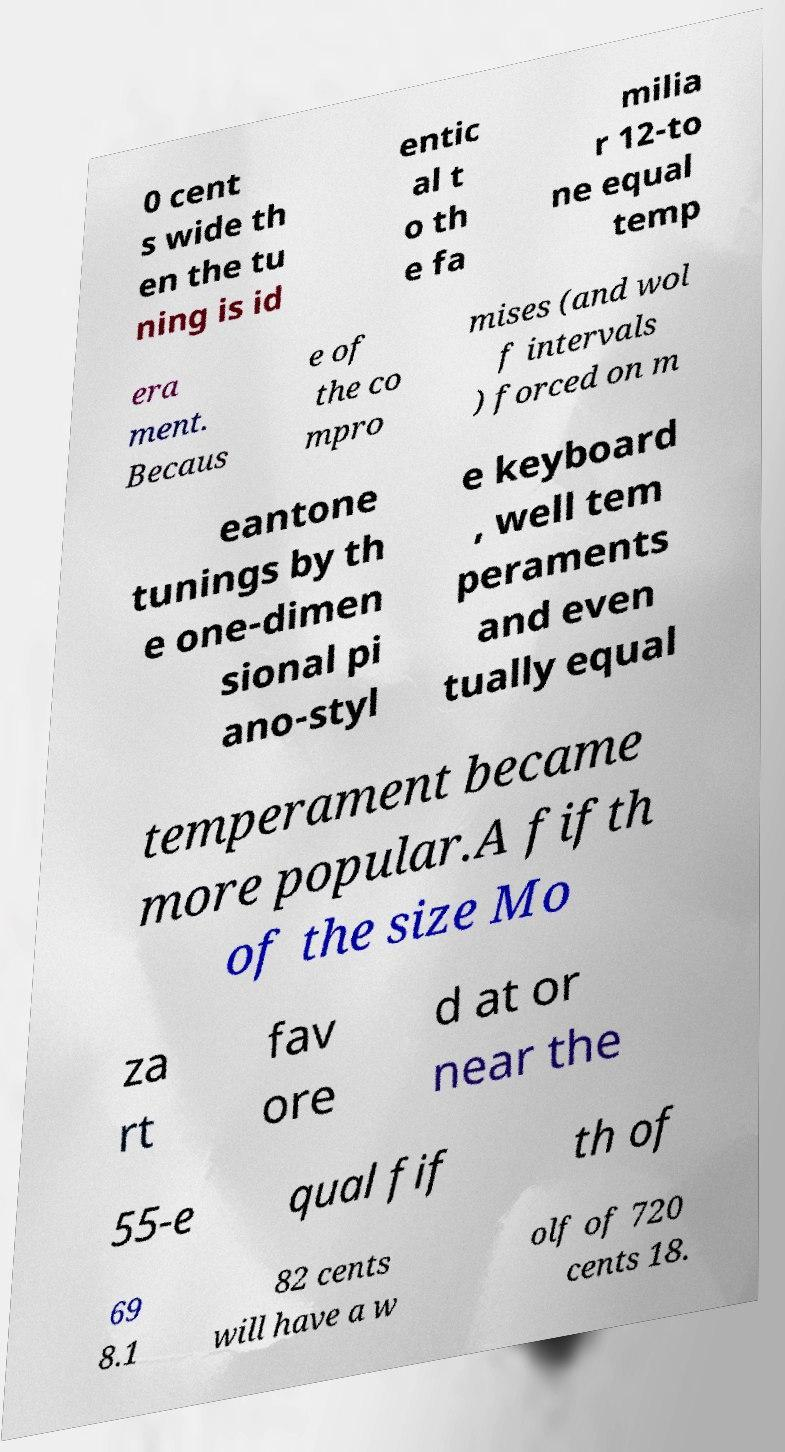Please identify and transcribe the text found in this image. 0 cent s wide th en the tu ning is id entic al t o th e fa milia r 12-to ne equal temp era ment. Becaus e of the co mpro mises (and wol f intervals ) forced on m eantone tunings by th e one-dimen sional pi ano-styl e keyboard , well tem peraments and even tually equal temperament became more popular.A fifth of the size Mo za rt fav ore d at or near the 55-e qual fif th of 69 8.1 82 cents will have a w olf of 720 cents 18. 